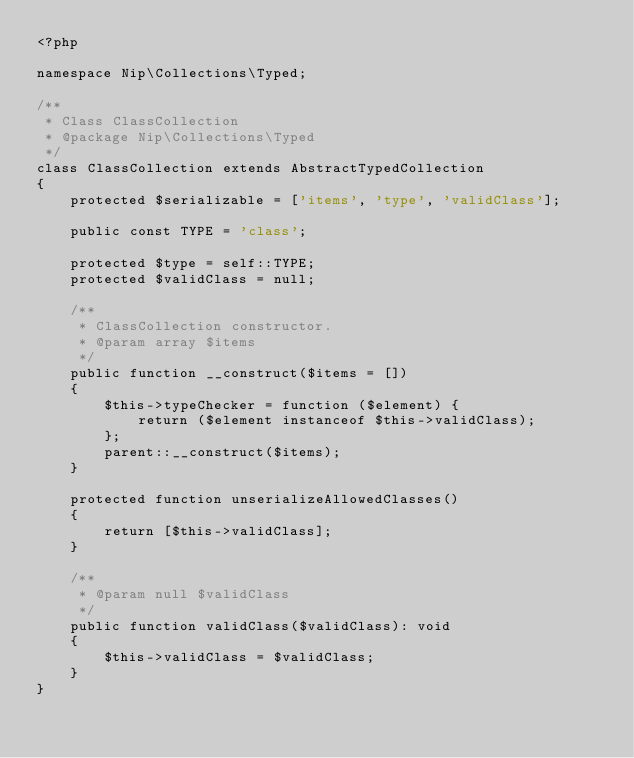Convert code to text. <code><loc_0><loc_0><loc_500><loc_500><_PHP_><?php

namespace Nip\Collections\Typed;

/**
 * Class ClassCollection
 * @package Nip\Collections\Typed
 */
class ClassCollection extends AbstractTypedCollection
{
    protected $serializable = ['items', 'type', 'validClass'];

    public const TYPE = 'class';

    protected $type = self::TYPE;
    protected $validClass = null;

    /**
     * ClassCollection constructor.
     * @param array $items
     */
    public function __construct($items = [])
    {
        $this->typeChecker = function ($element) {
            return ($element instanceof $this->validClass);
        };
        parent::__construct($items);
    }

    protected function unserializeAllowedClasses()
    {
        return [$this->validClass];
    }

    /**
     * @param null $validClass
     */
    public function validClass($validClass): void
    {
        $this->validClass = $validClass;
    }
}
</code> 